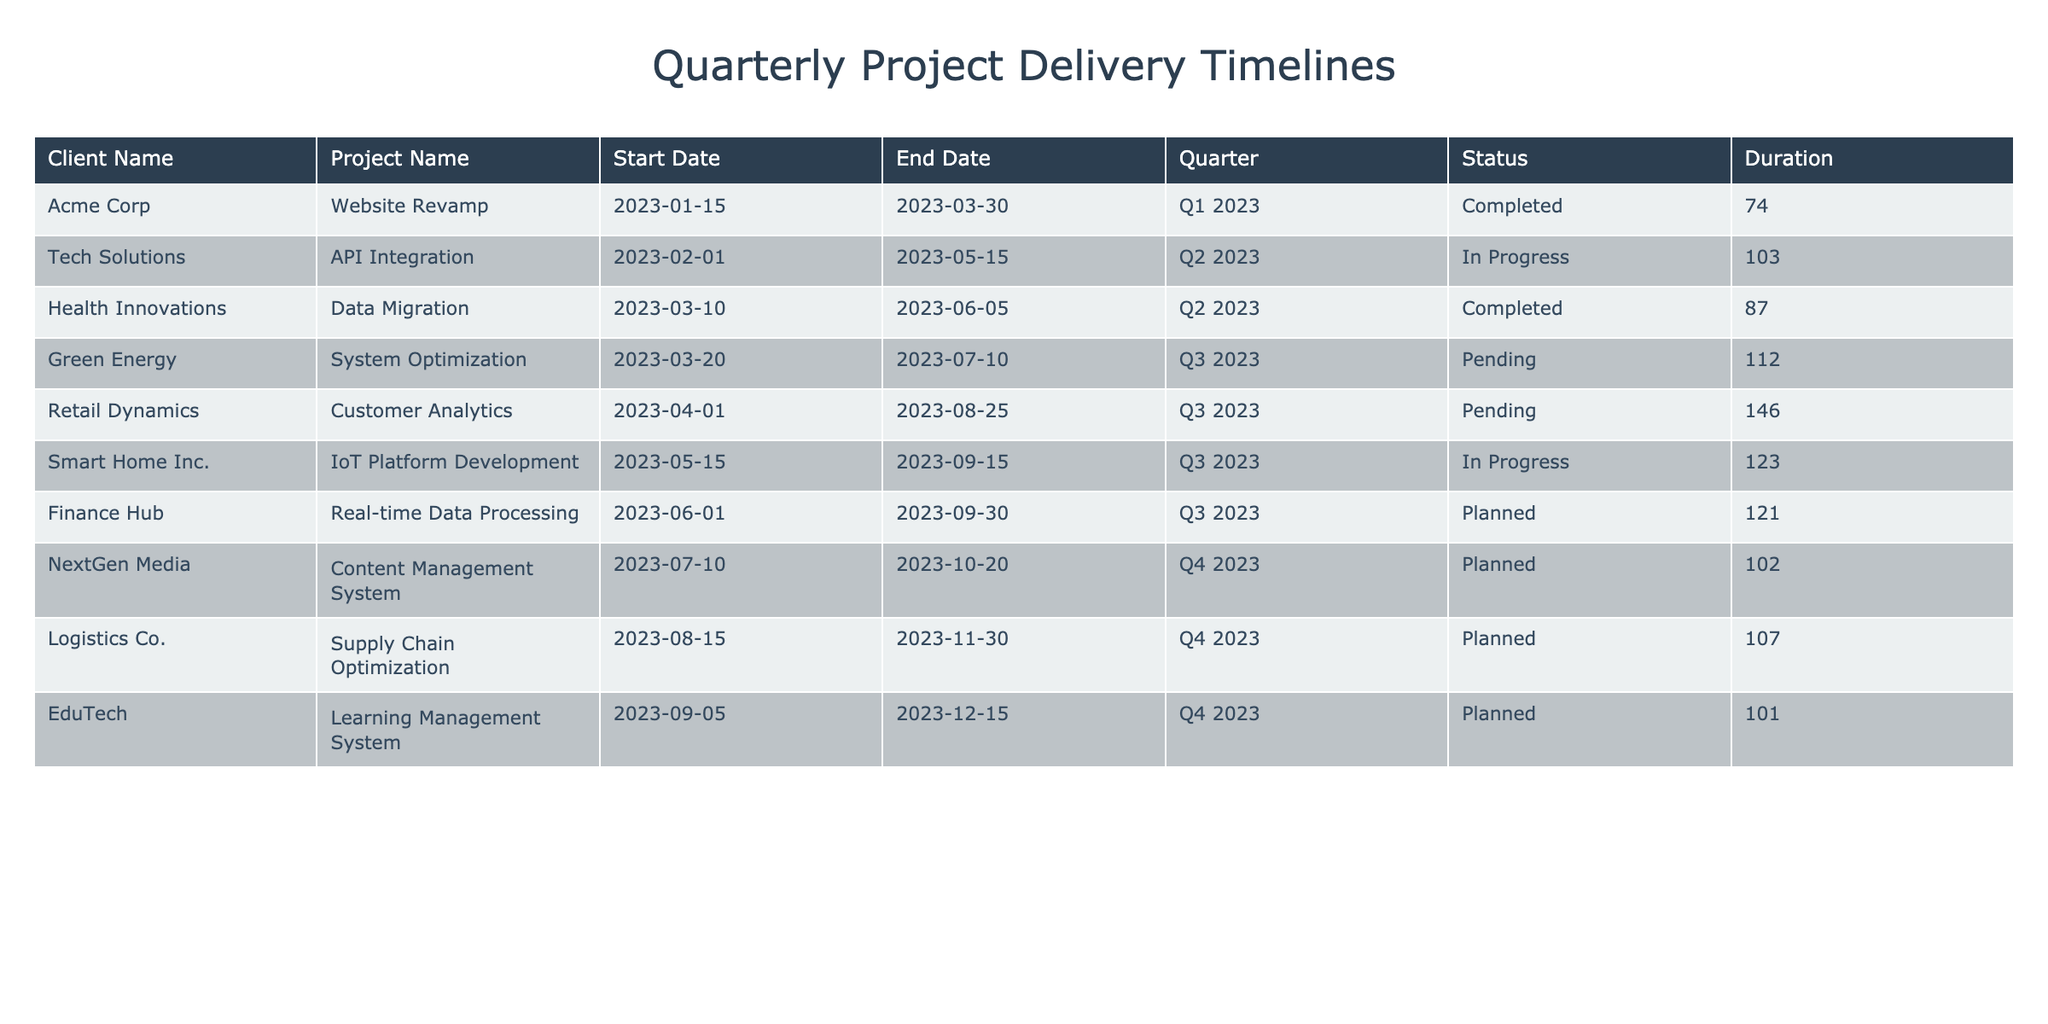What is the status of the project for Acme Corp? The table shows that Acme Corp's project "Website Revamp" has a status of "Completed."
Answer: Completed Which projects are currently in progress as of now? The table lists two projects with a status of "In Progress": "API Integration" for Tech Solutions and "IoT Platform Development" for Smart Home Inc.
Answer: API Integration, IoT Platform Development What is the duration of the project for Health Innovations? The table indicates that the project "Data Migration" for Health Innovations starts on March 10, 2023, and ends on June 5, 2023. This gives a duration of 87 days (from March 10 to June 5).
Answer: 87 days Are there any projects scheduled for Q4 2023? Yes, the table shows that there are three projects planned for Q4 2023: "Content Management System" for NextGen Media, "Supply Chain Optimization" for Logistics Co., and "Learning Management System" for EduTech.
Answer: Yes What is the average duration of projects in Q3 2023? The projects in Q3 2023 are "System Optimization," "Customer Analytics," and "IoT Platform Development." Their durations are 112 days, 146 days, and 122 days, respectively. The average duration is (112 + 146 + 122) / 3 = 380 / 3 = 126.67 days.
Answer: 126.67 days Which client has the longest project duration, and what is the duration? Among all projects, "Customer Analytics" for Retail Dynamics has the longest duration of 146 days (from April 1 to August 25).
Answer: Retail Dynamics, 146 days How many total projects are completed in Q2 2023? In Q2 2023, there are two projects: "API Integration" for Tech Solutions (In Progress) and "Data Migration" for Health Innovations (Completed). Therefore, only one project is completed.
Answer: 1 Do any projects have a pending status? Yes, there are three projects listed as pending: "System Optimization," "Customer Analytics," and "API Integration."
Answer: Yes What is the total number of clients having planned projects? The table lists three projects categorized as Planned; therefore, there are three clients: Finance Hub, NextGen Media, and Logistics Co.
Answer: 3 